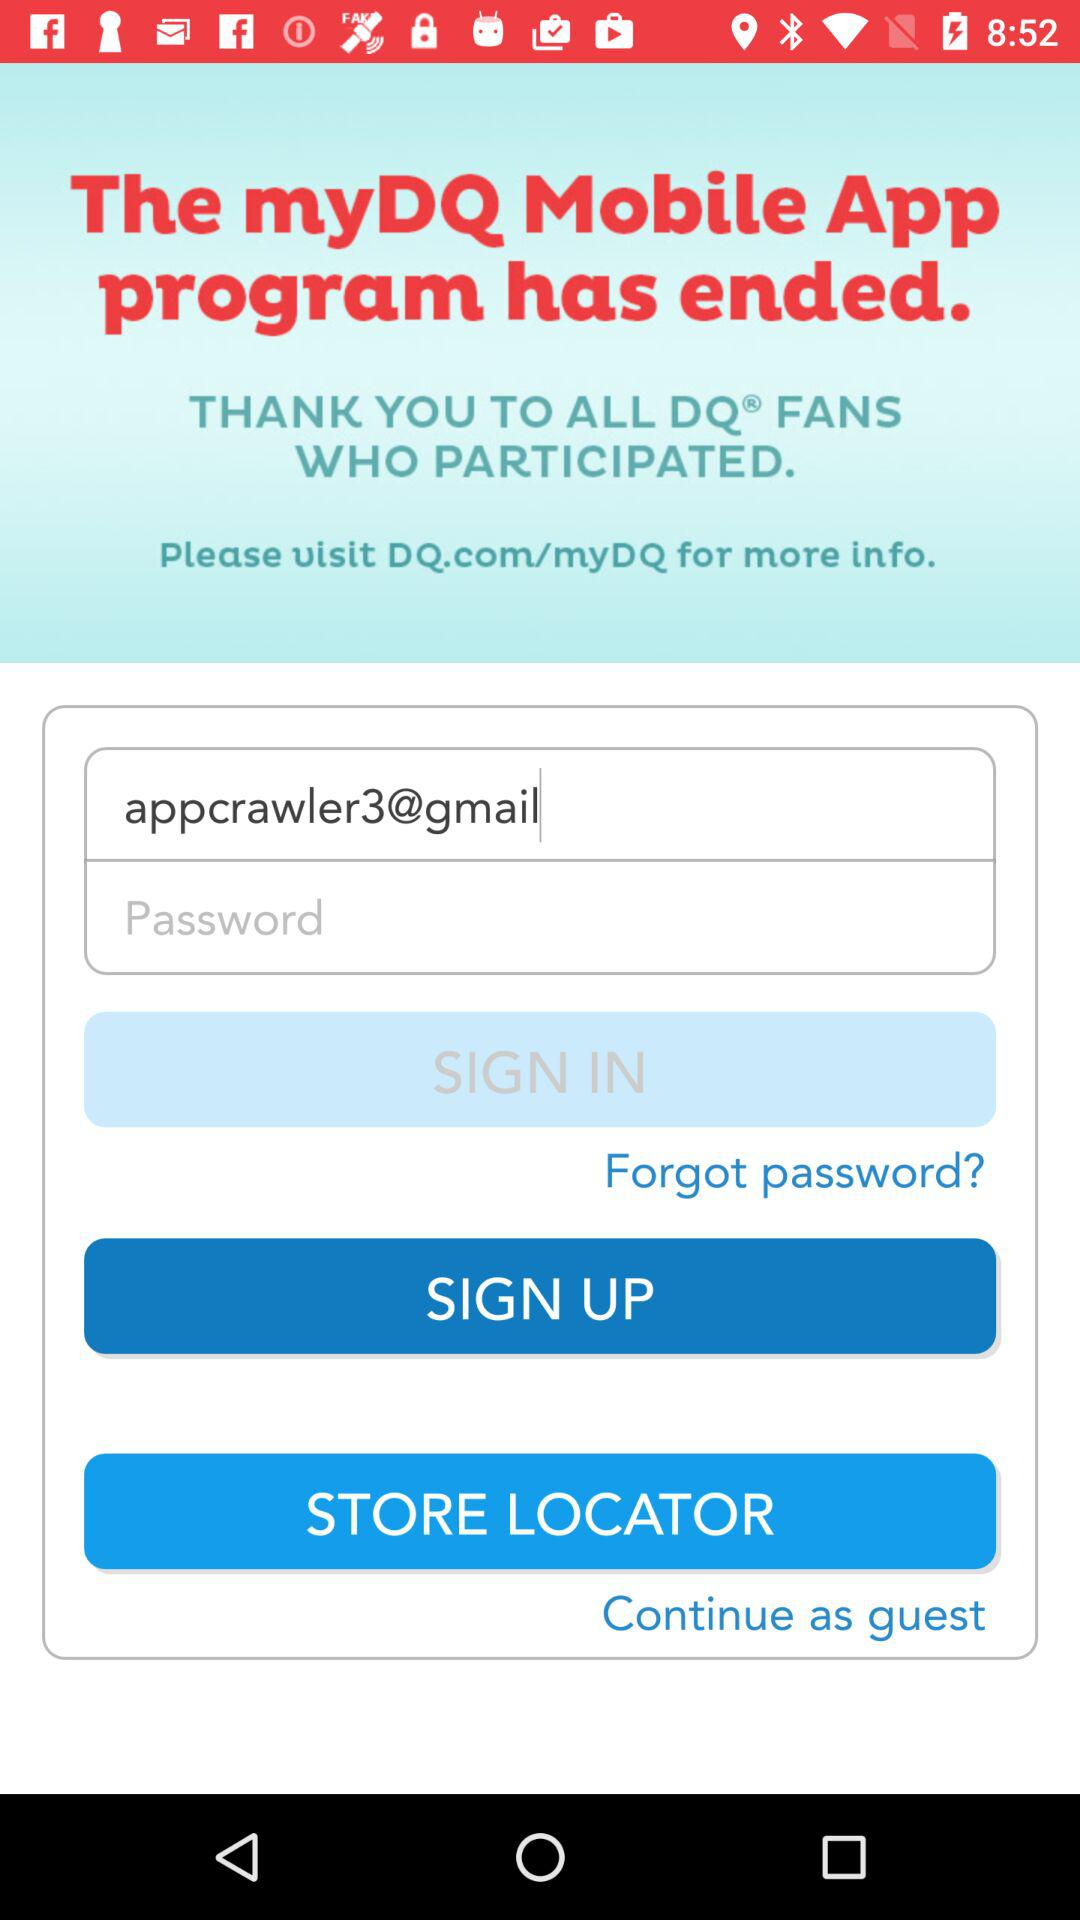What website can I visit for more information about "myDQ" mobile app? You can visit DQ.com/myDQ for more information. 